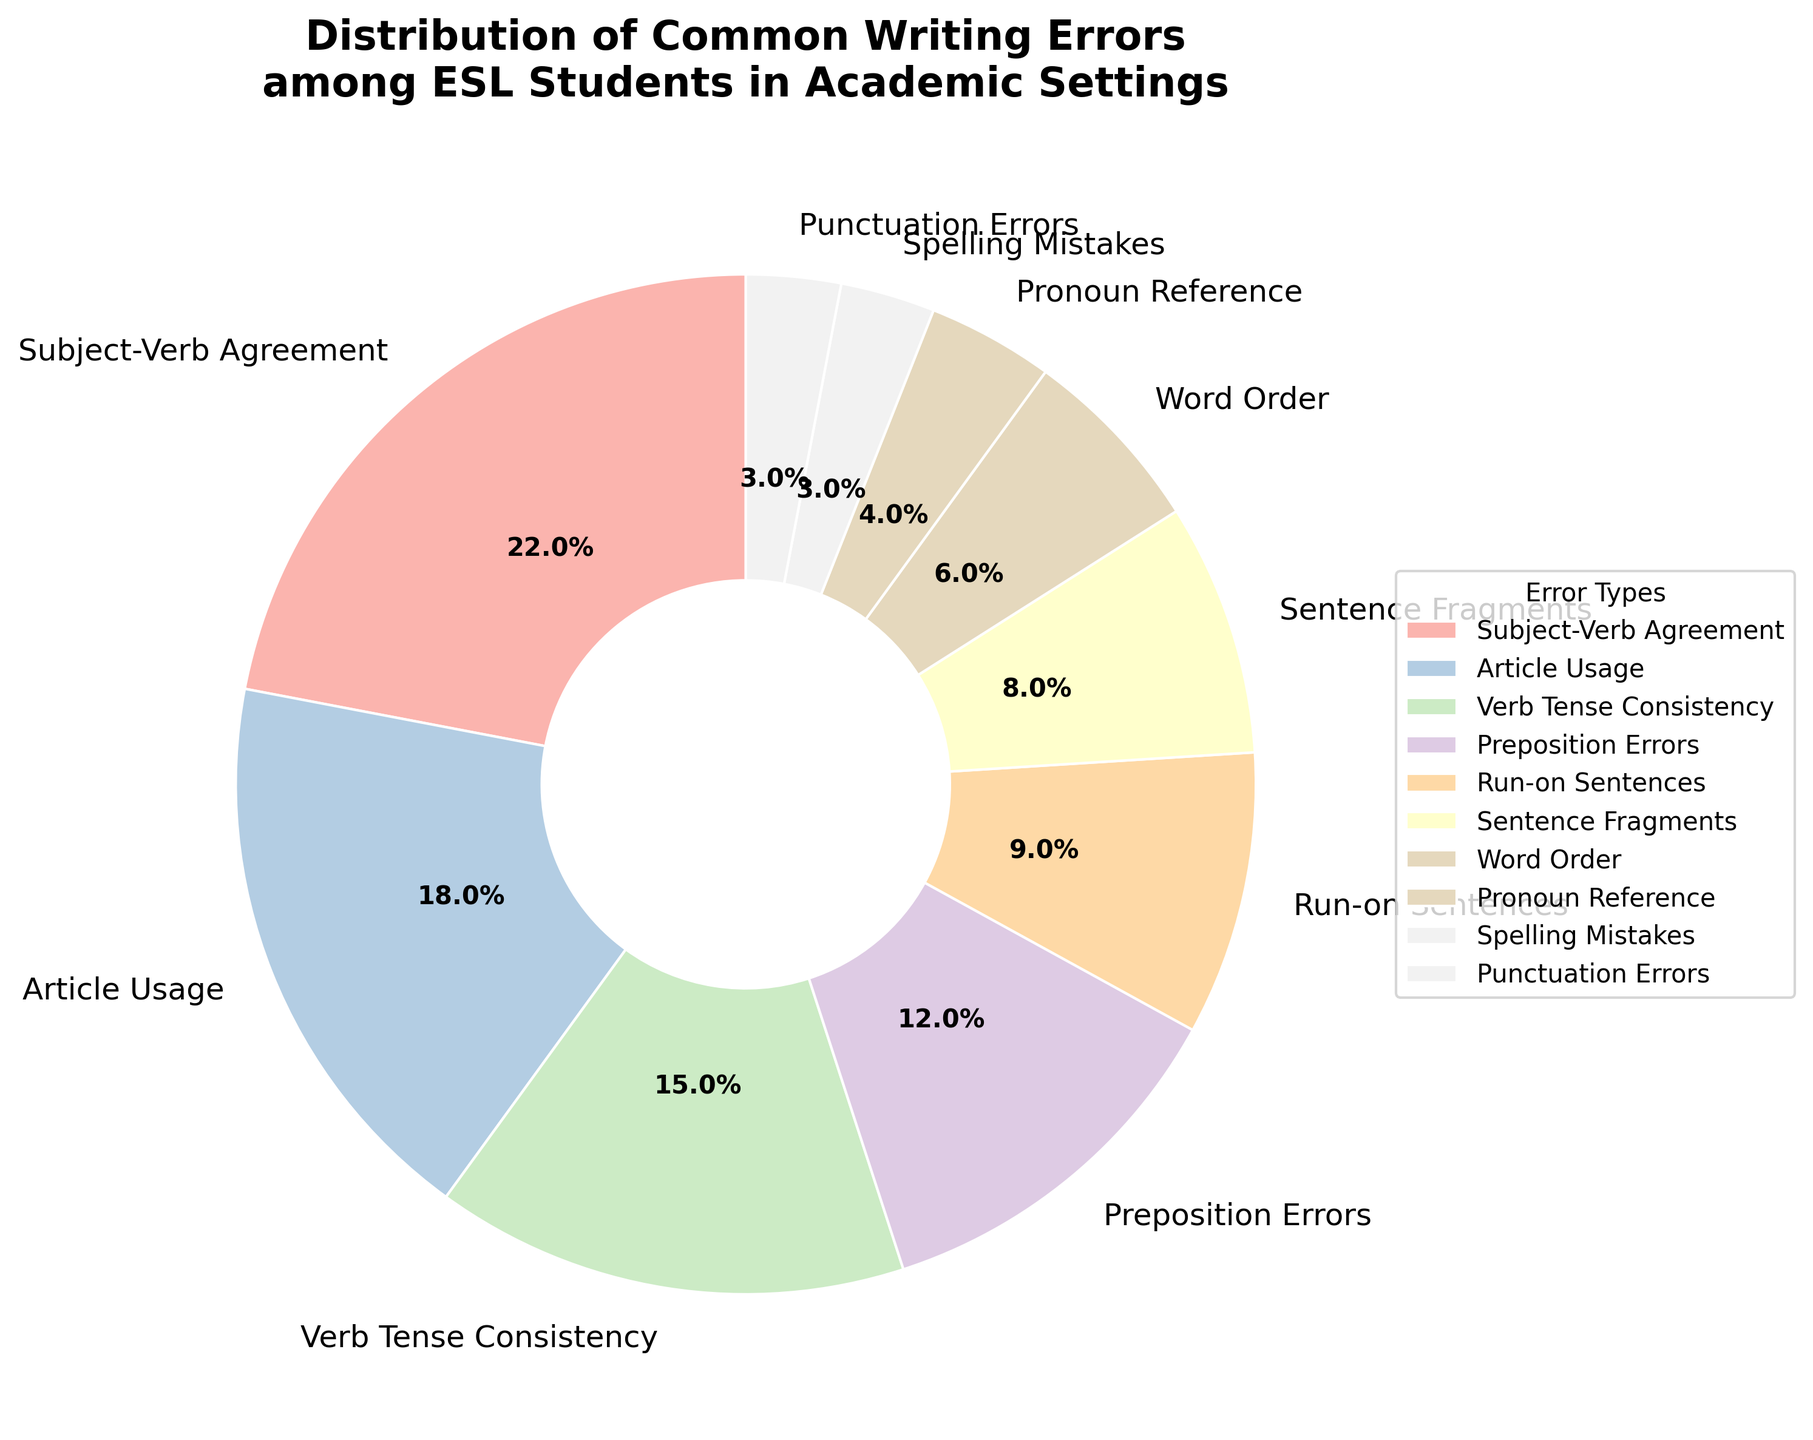what percentage of the total common writing errors are due to Article Usage and Verb Tense Consistency combined? To find the combined percentage, we need to sum the percentages of Article Usage (18%) and Verb Tense Consistency (15%). Adding these, we get 18% + 15% = 33%.
Answer: 33% Which error type has the least occurrence, and what is its percentage? By looking at the pie chart, the segment with the smallest piece represents the least occurrence. Spelling Mistakes and Punctuation Errors both have the smallest segments, each representing 3% of the total.
Answer: Spelling Mistakes, Punctuation Errors (3% each) Which error types combined account for over 50% of all errors? We need to sum the percentages in descending order and identify at which point the sum exceeds 50%. Subject-Verb Agreement (22%) + Article Usage (18%) + Verb Tense Consistency (15%) = 55%. These three combined account for over 50% of the errors.
Answer: Subject-Verb Agreement, Article Usage, Verb Tense Consistency How does the percentage of Preposition Errors compare to that of Word Order? Looking at the pie chart, Preposition Errors is 12%, and Word Order is 6%. Preposition Errors are twice the amount of Word Order errors.
Answer: Preposition Errors are twice Word Order What is the combined percentage of errors contributed by Run-on Sentences, Sentence Fragments, and Pronoun Reference? Sum the percentages of Run-on Sentences (9%), Sentence Fragments (8%), and Pronoun Reference (4%). Adding these, we get 9% + 8% + 4% = 21%.
Answer: 21% What is the visual indicator for the error type with the highest percentage? The error type with the highest percentage is Subject-Verb Agreement, and its segment is the largest in the pie chart. It’s visually the largest sector.
Answer: Largest sector Which four error types have the smallest segments, and what are their percentages? From the pie chart, the four smallest segments are for Word Order (6%), Pronoun Reference (4%), Spelling Mistakes (3%), and Punctuation Errors (3%). Their percentages are 6%, 4%, 3%, and 3% respectively.
Answer: Word Order (6%), Pronoun Reference (4%), Spelling Mistakes (3%), Punctuation Errors (3%) What percentage of errors are related to sentence structure issues (Run-on Sentences and Sentence Fragments)? Sum the percentages for Run-on Sentences (9%) and Sentence Fragments (8%). Adding these, we get 9% + 8% = 17%.
Answer: 17% If you combine the percentages for Article Usage, Verb Tense Consistency, and Preposition Errors, do they surpass Subject-Verb Agreement errors? Sum the percentages for Article Usage (18%), Verb Tense Consistency (15%), and Preposition Errors (12%). Adding these, we get 18% + 15% + 12% = 45%. Compare this with Subject-Verb Agreement, which is 22%. Yes, the combined percentage (45%) surpasses Subject-Verb Agreement (22%).
Answer: Yes, 45% surpasses 22% What error types together contribute to the second and third largest error percentages and what are their combined percentages? The second largest error type is Article Usage (18%), and the third largest is Verb Tense Consistency (15%). Adding these, we get 18% + 15% = 33%.
Answer: Article Usage, Verb Tense Consistency (33%) 